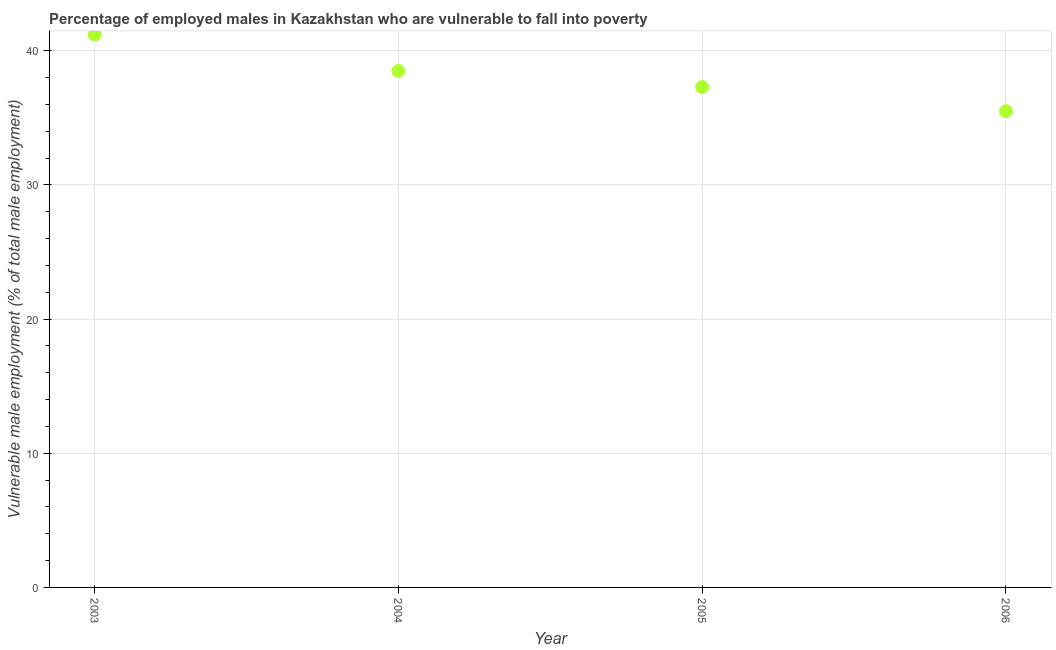What is the percentage of employed males who are vulnerable to fall into poverty in 2006?
Offer a terse response. 35.5. Across all years, what is the maximum percentage of employed males who are vulnerable to fall into poverty?
Your answer should be compact. 41.2. Across all years, what is the minimum percentage of employed males who are vulnerable to fall into poverty?
Offer a terse response. 35.5. In which year was the percentage of employed males who are vulnerable to fall into poverty minimum?
Keep it short and to the point. 2006. What is the sum of the percentage of employed males who are vulnerable to fall into poverty?
Provide a short and direct response. 152.5. What is the difference between the percentage of employed males who are vulnerable to fall into poverty in 2005 and 2006?
Provide a short and direct response. 1.8. What is the average percentage of employed males who are vulnerable to fall into poverty per year?
Your answer should be compact. 38.12. What is the median percentage of employed males who are vulnerable to fall into poverty?
Make the answer very short. 37.9. In how many years, is the percentage of employed males who are vulnerable to fall into poverty greater than 14 %?
Give a very brief answer. 4. Do a majority of the years between 2005 and 2003 (inclusive) have percentage of employed males who are vulnerable to fall into poverty greater than 38 %?
Keep it short and to the point. No. What is the ratio of the percentage of employed males who are vulnerable to fall into poverty in 2003 to that in 2006?
Your answer should be very brief. 1.16. Is the percentage of employed males who are vulnerable to fall into poverty in 2003 less than that in 2006?
Your response must be concise. No. What is the difference between the highest and the second highest percentage of employed males who are vulnerable to fall into poverty?
Provide a succinct answer. 2.7. Is the sum of the percentage of employed males who are vulnerable to fall into poverty in 2003 and 2006 greater than the maximum percentage of employed males who are vulnerable to fall into poverty across all years?
Keep it short and to the point. Yes. What is the difference between the highest and the lowest percentage of employed males who are vulnerable to fall into poverty?
Keep it short and to the point. 5.7. What is the difference between two consecutive major ticks on the Y-axis?
Provide a succinct answer. 10. Are the values on the major ticks of Y-axis written in scientific E-notation?
Your response must be concise. No. Does the graph contain any zero values?
Ensure brevity in your answer.  No. What is the title of the graph?
Provide a succinct answer. Percentage of employed males in Kazakhstan who are vulnerable to fall into poverty. What is the label or title of the Y-axis?
Provide a succinct answer. Vulnerable male employment (% of total male employment). What is the Vulnerable male employment (% of total male employment) in 2003?
Keep it short and to the point. 41.2. What is the Vulnerable male employment (% of total male employment) in 2004?
Offer a terse response. 38.5. What is the Vulnerable male employment (% of total male employment) in 2005?
Offer a very short reply. 37.3. What is the Vulnerable male employment (% of total male employment) in 2006?
Give a very brief answer. 35.5. What is the difference between the Vulnerable male employment (% of total male employment) in 2003 and 2005?
Give a very brief answer. 3.9. What is the difference between the Vulnerable male employment (% of total male employment) in 2004 and 2005?
Ensure brevity in your answer.  1.2. What is the ratio of the Vulnerable male employment (% of total male employment) in 2003 to that in 2004?
Your answer should be compact. 1.07. What is the ratio of the Vulnerable male employment (% of total male employment) in 2003 to that in 2005?
Your response must be concise. 1.1. What is the ratio of the Vulnerable male employment (% of total male employment) in 2003 to that in 2006?
Provide a succinct answer. 1.16. What is the ratio of the Vulnerable male employment (% of total male employment) in 2004 to that in 2005?
Keep it short and to the point. 1.03. What is the ratio of the Vulnerable male employment (% of total male employment) in 2004 to that in 2006?
Your response must be concise. 1.08. What is the ratio of the Vulnerable male employment (% of total male employment) in 2005 to that in 2006?
Your answer should be compact. 1.05. 